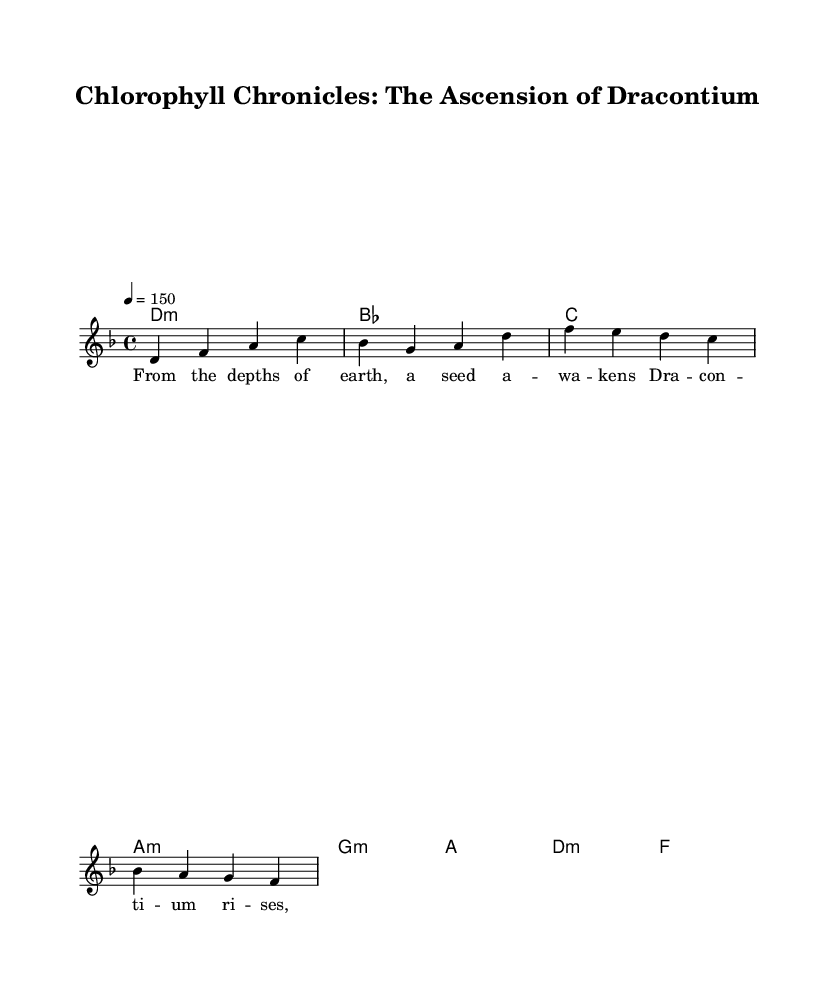What is the key signature of this music? The key signature is indicated at the beginning of the piece. Since there are no sharps or flats shown, the key signature is D minor.
Answer: D minor What is the time signature of this music? The time signature is found at the beginning of the score. It is written as 4/4, indicating four beats per measure.
Answer: 4/4 What is the tempo marking of this music? The tempo marking indicates the speed of the piece. It states "4 = 150," meaning there are 150 beats per minute.
Answer: 150 How many measures are in the music? To count the number of measures, one must look at the staff lines and note groupings. This example has 4 measures visible in the melody line.
Answer: 4 What genre does this music represent? The title "Chlorophyll Chronicles: The Ascension of Dracontium" and the heavy use of underlying harmonies and lyrical themes suggest that it represents the symphonic metal genre.
Answer: Symphonic metal What type of lyrics are featured in this music? The lyrics are narrative, as they tell the story of a seed awakening and the journey of the plant Dracontium, reflecting a theme common in symphonic metal.
Answer: Narrative What is the first note of the melody? The first note of the melody is indicated at the beginning of the melody line, which is a D note.
Answer: D 